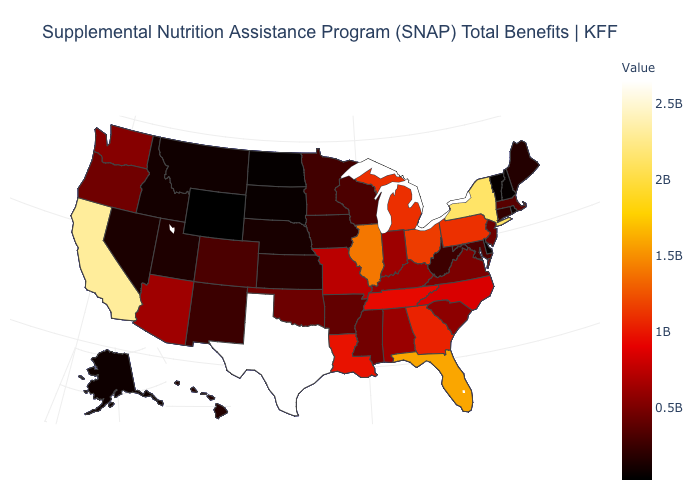Is the legend a continuous bar?
Give a very brief answer. Yes. Does Arizona have the lowest value in the West?
Keep it brief. No. Does Kansas have the highest value in the MidWest?
Be succinct. No. Does Alabama have a lower value than Minnesota?
Be succinct. No. Which states have the highest value in the USA?
Quick response, please. Texas. Which states have the lowest value in the West?
Write a very short answer. Wyoming. Which states have the lowest value in the West?
Answer briefly. Wyoming. 